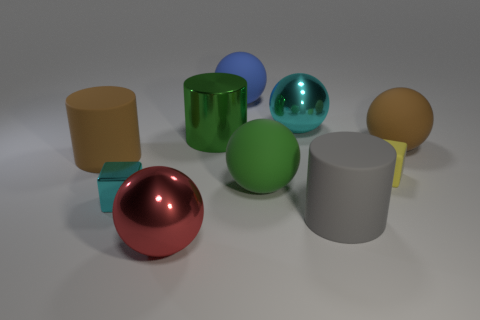Subtract all cyan balls. How many balls are left? 4 Subtract all big metallic spheres. How many spheres are left? 3 Subtract all gray balls. Subtract all red cylinders. How many balls are left? 5 Subtract all cylinders. How many objects are left? 7 Add 4 large cyan things. How many large cyan things exist? 5 Subtract 0 gray cubes. How many objects are left? 10 Subtract all big green balls. Subtract all tiny metallic cubes. How many objects are left? 8 Add 8 metal balls. How many metal balls are left? 10 